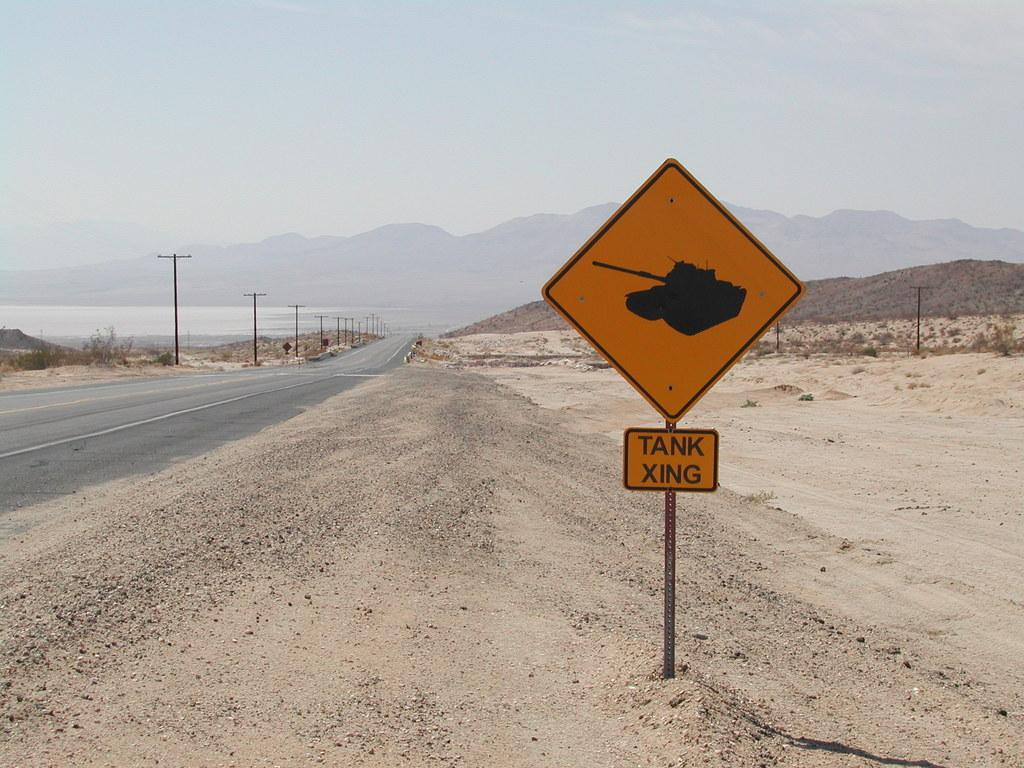<image>
Write a terse but informative summary of the picture. A yellow sign on the side of a desert road that indicates a tank crossing. 